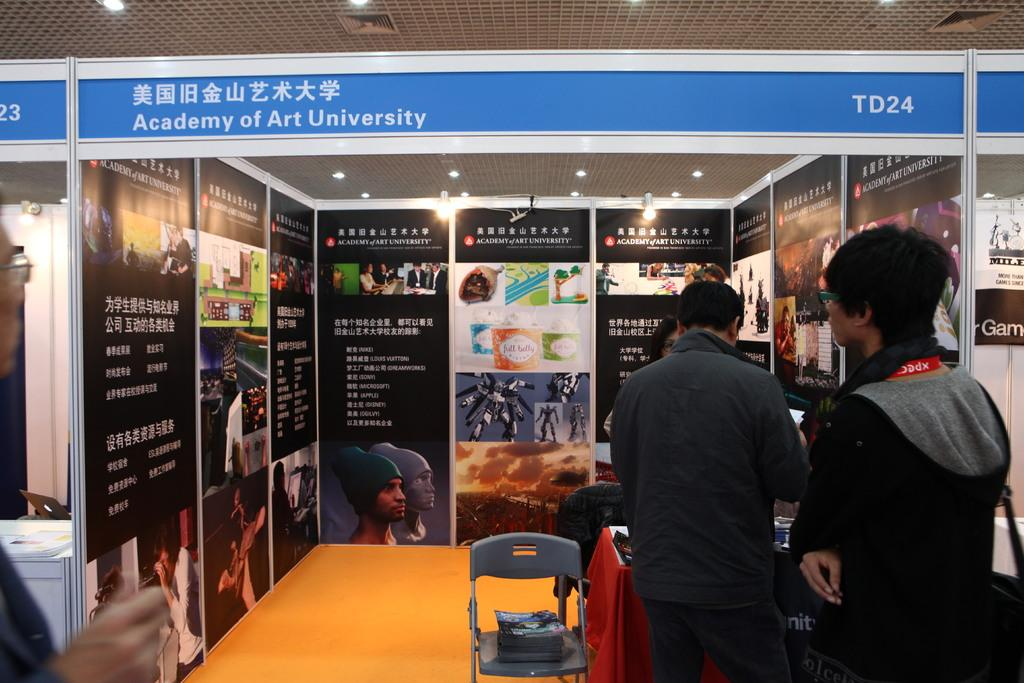What is happening in the image? There are persons standing in the image. Can you describe the objects near the persons? There is a box on a chair and a table with a red cloth in front of the persons. What type of decorations are visible in the image? There are different types of posters in the image. What type of suit is the person wearing in the image? There is no information about the person's clothing in the image, so we cannot determine if they are wearing a suit or not. What is the person carrying on the tray in the image? There is no tray present in the image. 